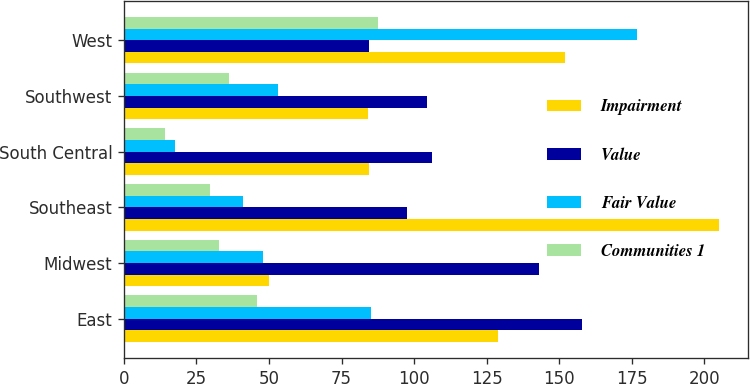Convert chart. <chart><loc_0><loc_0><loc_500><loc_500><stacked_bar_chart><ecel><fcel>East<fcel>Midwest<fcel>Southeast<fcel>South Central<fcel>Southwest<fcel>West<nl><fcel>Impairment<fcel>129<fcel>50<fcel>205<fcel>84.55<fcel>84<fcel>152<nl><fcel>Value<fcel>157.8<fcel>143<fcel>97.5<fcel>106.2<fcel>104.3<fcel>84.55<nl><fcel>Fair Value<fcel>85.1<fcel>47.8<fcel>40.9<fcel>17.7<fcel>53<fcel>176.8<nl><fcel>Communities 1<fcel>45.9<fcel>32.8<fcel>29.8<fcel>14.2<fcel>36.2<fcel>87.5<nl></chart> 